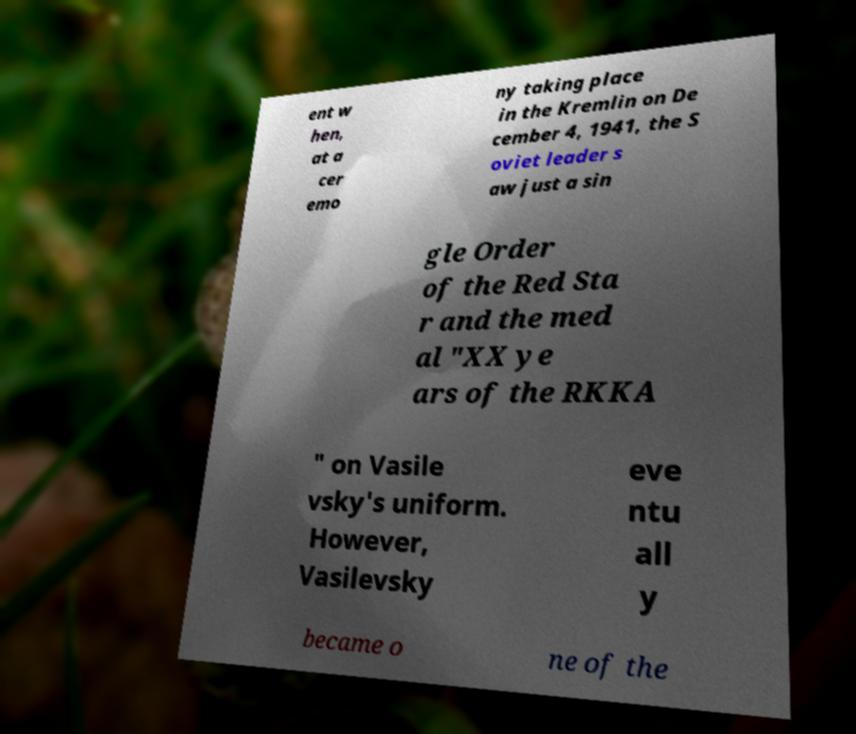Please read and relay the text visible in this image. What does it say? ent w hen, at a cer emo ny taking place in the Kremlin on De cember 4, 1941, the S oviet leader s aw just a sin gle Order of the Red Sta r and the med al "XX ye ars of the RKKA " on Vasile vsky's uniform. However, Vasilevsky eve ntu all y became o ne of the 